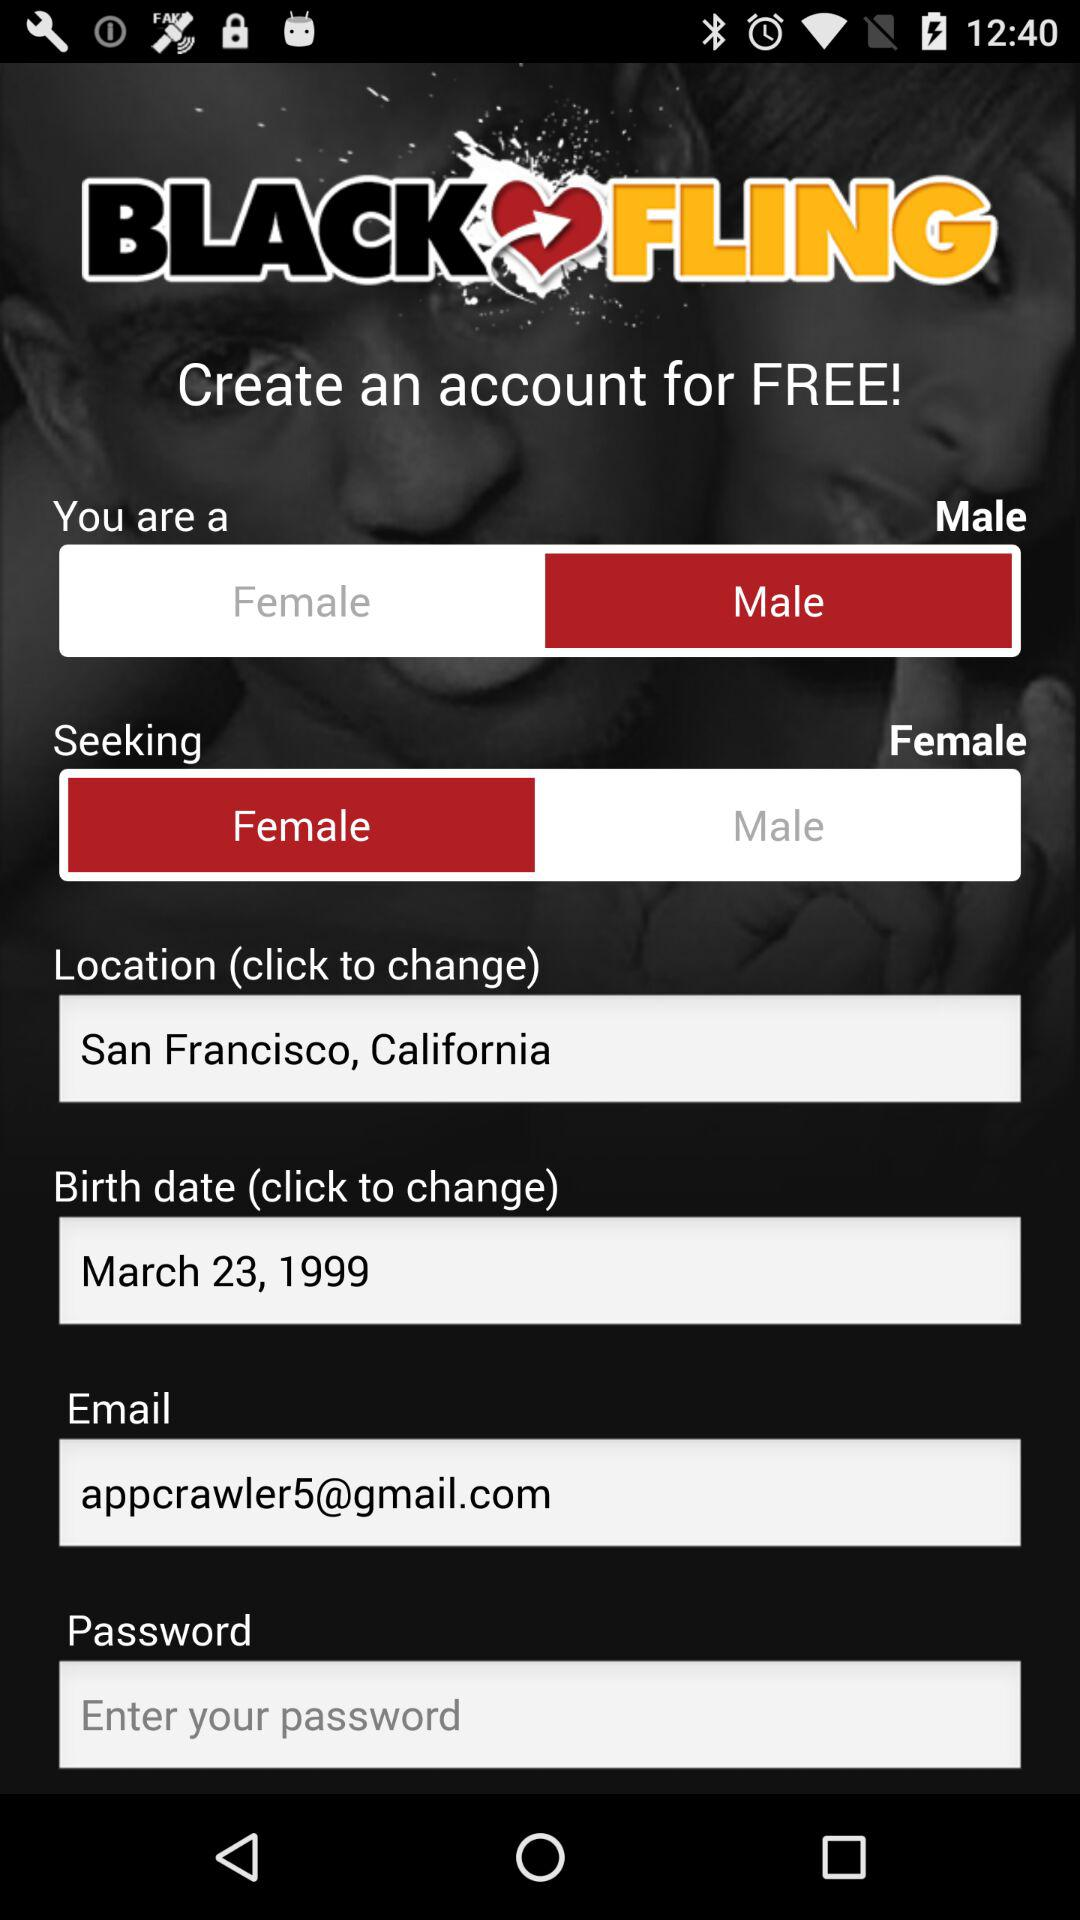Which gender is selected in "You are a"? The selected gender is "Male". 